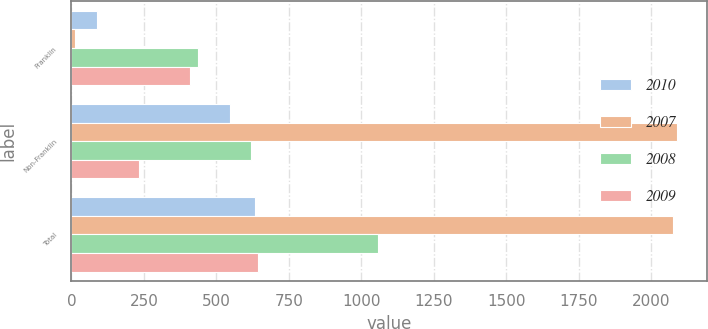<chart> <loc_0><loc_0><loc_500><loc_500><stacked_bar_chart><ecel><fcel>Franklin<fcel>Non-Franklin<fcel>Total<nl><fcel>2010<fcel>87<fcel>547.5<fcel>634.5<nl><fcel>2007<fcel>14.1<fcel>2088.8<fcel>2074.7<nl><fcel>2008<fcel>438<fcel>619.5<fcel>1057.5<nl><fcel>2009<fcel>410.8<fcel>232.8<fcel>643.6<nl></chart> 